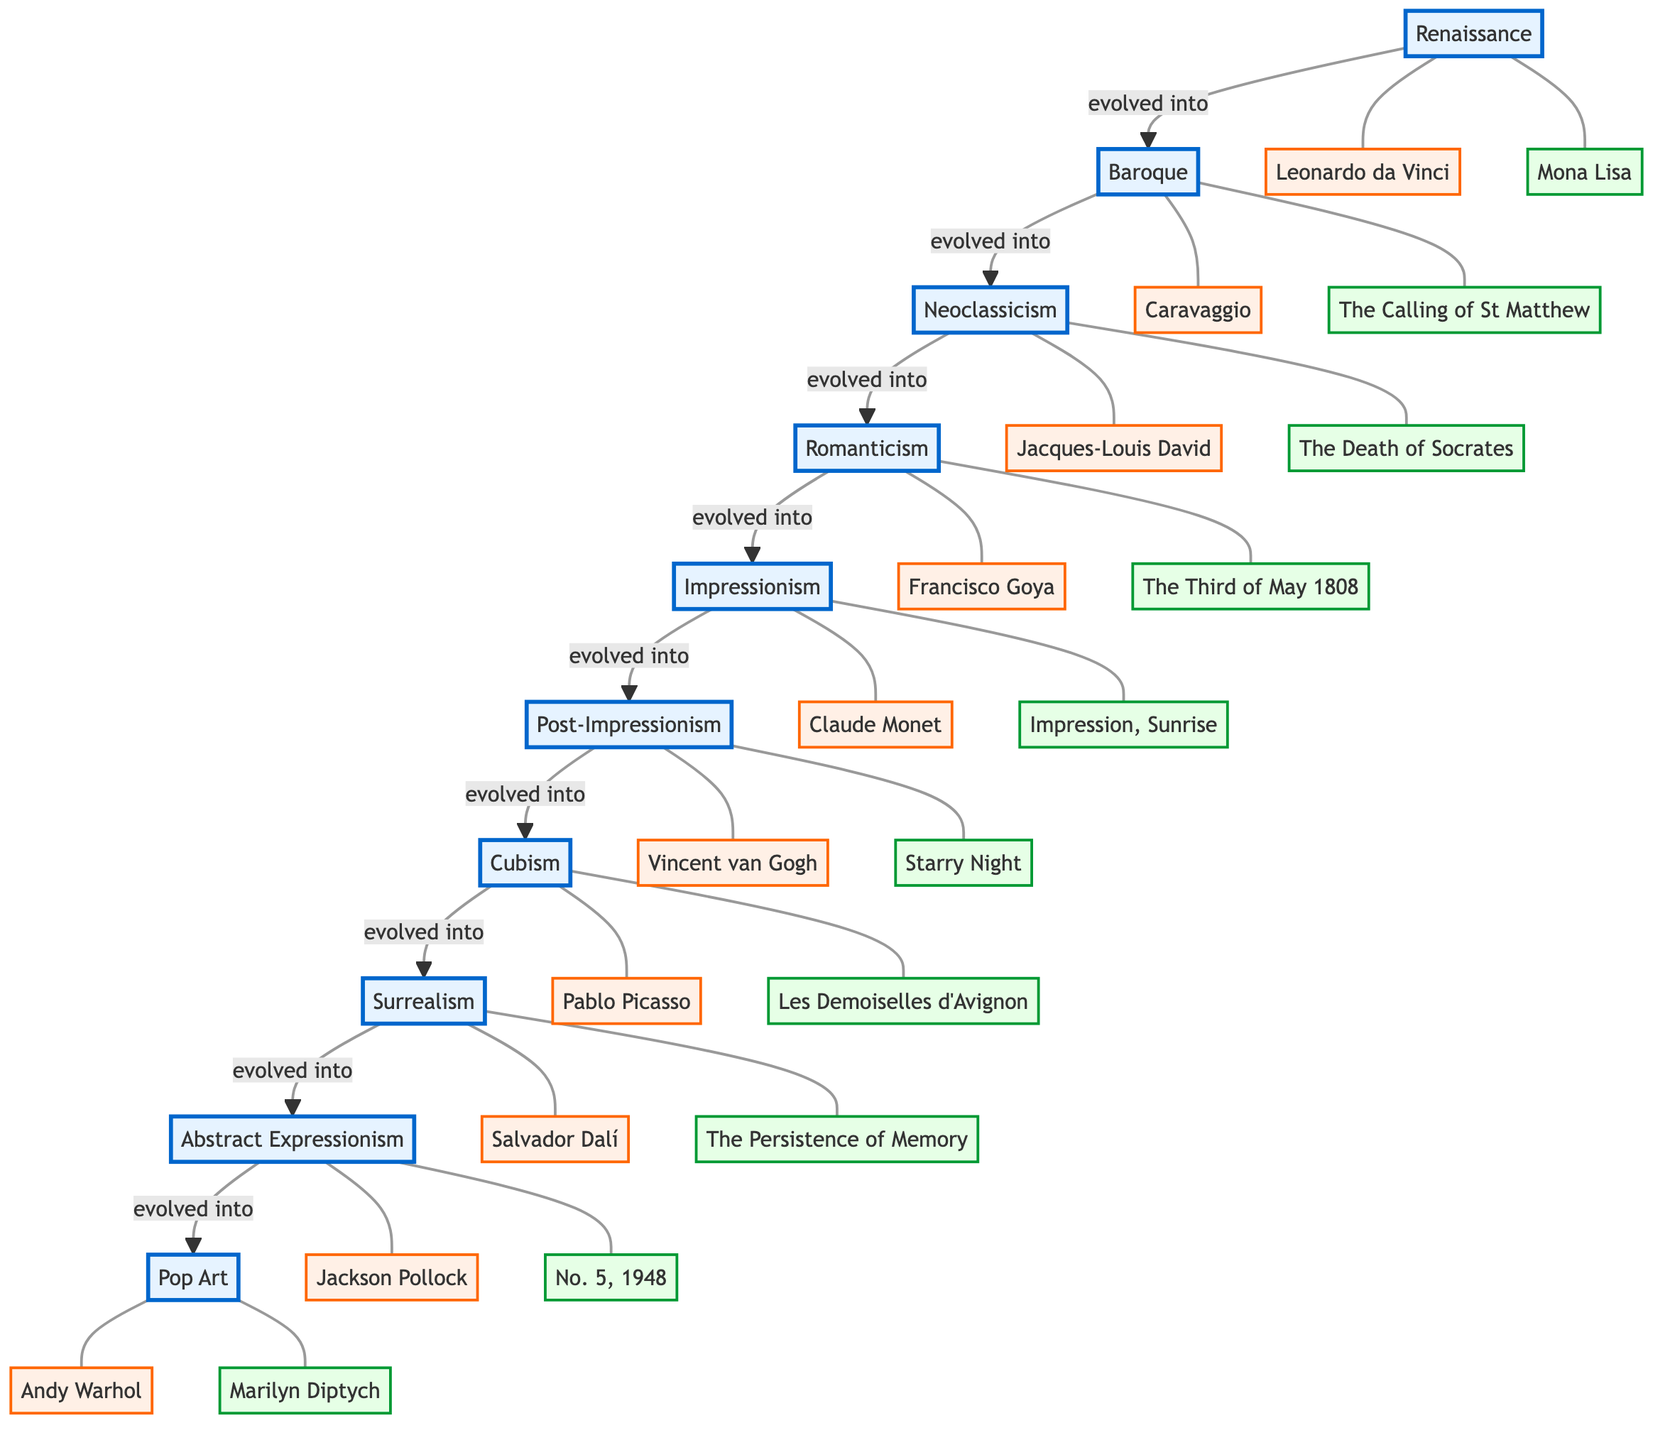What is the first art movement listed in the diagram? The diagram indicates that the first node, representing the earliest art movement, is labeled "Renaissance."
Answer: Renaissance How many major art movements are depicted in the diagram? There are ten distinct art movements shown in the flowchart, each represented by a separate movement node.
Answer: 10 Who is the key artist associated with Cubism? The diagram connects the movement "Cubism" to the artist "Pablo Picasso," who is identified as a key figure in that movement.
Answer: Pablo Picasso What artwork is linked to Surrealism? The connection from the Surrealism node leads to "The Persistence of Memory," indicating it is the significant artwork associated with this movement.
Answer: The Persistence of Memory Which movement follows Impressionism in the evolution sequence? The diagram shows that "Post-Impressionism" directly follows "Impressionism," indicating the progression of art movements.
Answer: Post-Impressionism Who created the artwork "Starry Night"? The flowchart associates the artwork "Starry Night" with the artist "Vincent van Gogh," showing his importance in the Post-Impressionism movement.
Answer: Vincent van Gogh What are the two movements that evolved before Cubism? Tracing back from Cubism in the diagram, "Post-Impressionism" and "Impressionism" are identified as the two movements that precede it in the evolution.
Answer: Post-Impressionism, Impressionism What is the last art movement in the sequence? The final node in the flowchart is labeled "Pop Art," marking it as the last movement in the evolutionary path shown.
Answer: Pop Art Which artist is linked to the artwork "The Calling of St Matthew"? The diagram shows that the artwork "The Calling of St Matthew" is linked to the artist "Caravaggio," highlighting his association with the Baroque movement.
Answer: Caravaggio How does the movement Romanticism relate to Neoclassicism? According to the diagram, "Romanticism" evolves from "Neoclassicism," indicating a direct relationship in the chronological sequence of art movements.
Answer: evolved into 